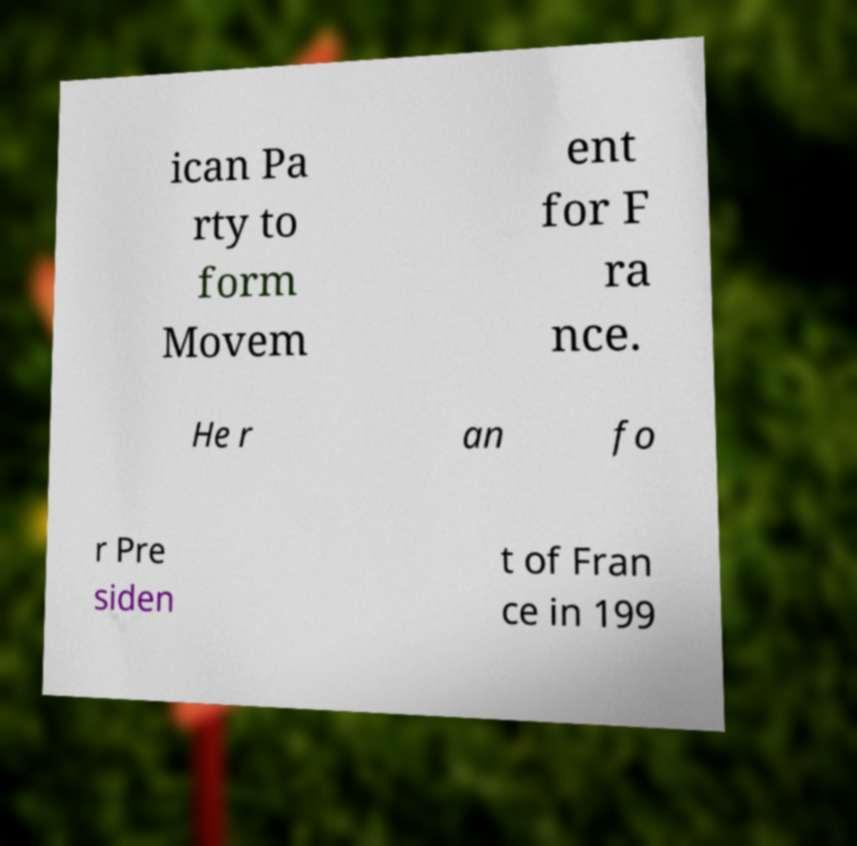What messages or text are displayed in this image? I need them in a readable, typed format. ican Pa rty to form Movem ent for F ra nce. He r an fo r Pre siden t of Fran ce in 199 